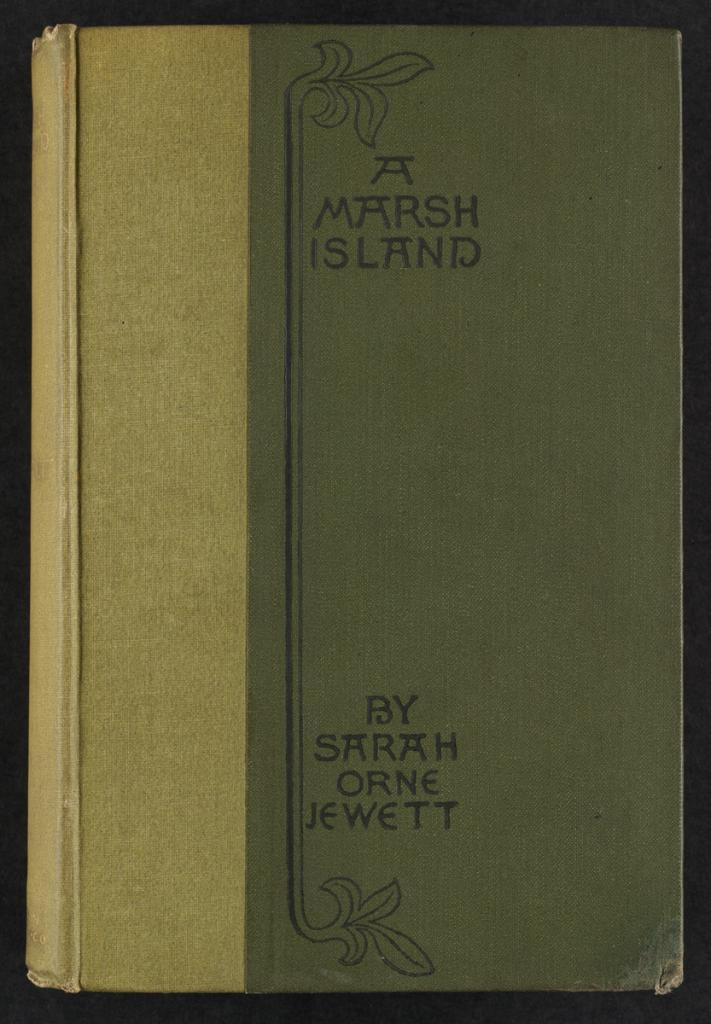<image>
Summarize the visual content of the image. A Marsh Island by Sarah Orne Jewett sits on a shelf. 